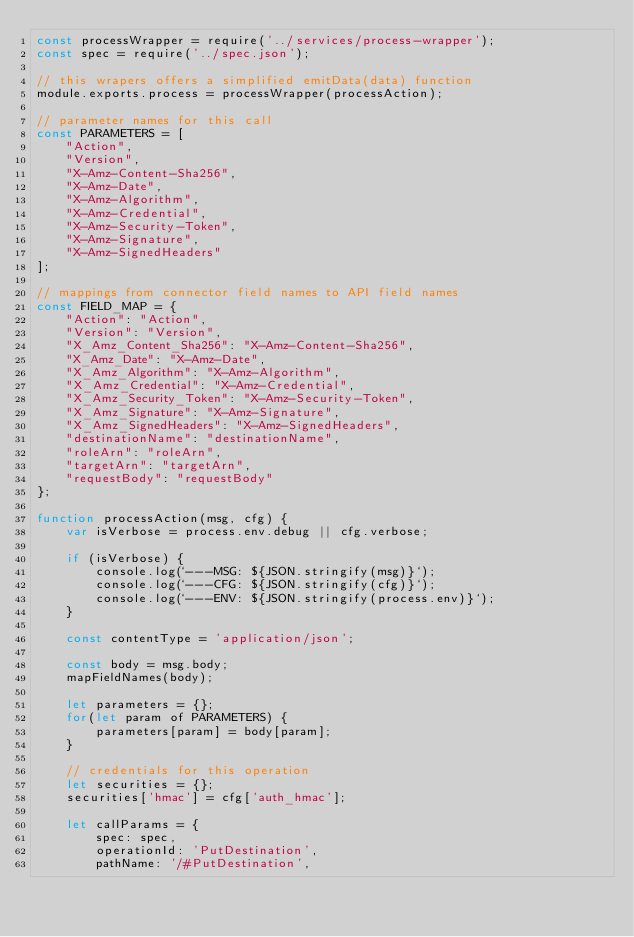<code> <loc_0><loc_0><loc_500><loc_500><_JavaScript_>const processWrapper = require('../services/process-wrapper');
const spec = require('../spec.json');

// this wrapers offers a simplified emitData(data) function
module.exports.process = processWrapper(processAction);

// parameter names for this call
const PARAMETERS = [
    "Action",
    "Version",
    "X-Amz-Content-Sha256",
    "X-Amz-Date",
    "X-Amz-Algorithm",
    "X-Amz-Credential",
    "X-Amz-Security-Token",
    "X-Amz-Signature",
    "X-Amz-SignedHeaders"
];

// mappings from connector field names to API field names
const FIELD_MAP = {
    "Action": "Action",
    "Version": "Version",
    "X_Amz_Content_Sha256": "X-Amz-Content-Sha256",
    "X_Amz_Date": "X-Amz-Date",
    "X_Amz_Algorithm": "X-Amz-Algorithm",
    "X_Amz_Credential": "X-Amz-Credential",
    "X_Amz_Security_Token": "X-Amz-Security-Token",
    "X_Amz_Signature": "X-Amz-Signature",
    "X_Amz_SignedHeaders": "X-Amz-SignedHeaders",
    "destinationName": "destinationName",
    "roleArn": "roleArn",
    "targetArn": "targetArn",
    "requestBody": "requestBody"
};

function processAction(msg, cfg) {
    var isVerbose = process.env.debug || cfg.verbose;

    if (isVerbose) {
        console.log(`---MSG: ${JSON.stringify(msg)}`);
        console.log(`---CFG: ${JSON.stringify(cfg)}`);
        console.log(`---ENV: ${JSON.stringify(process.env)}`);
    }

    const contentType = 'application/json';

    const body = msg.body;
    mapFieldNames(body);

    let parameters = {};
    for(let param of PARAMETERS) {
        parameters[param] = body[param];
    }

    // credentials for this operation
    let securities = {};
    securities['hmac'] = cfg['auth_hmac'];

    let callParams = {
        spec: spec,
        operationId: 'PutDestination',
        pathName: '/#PutDestination',</code> 